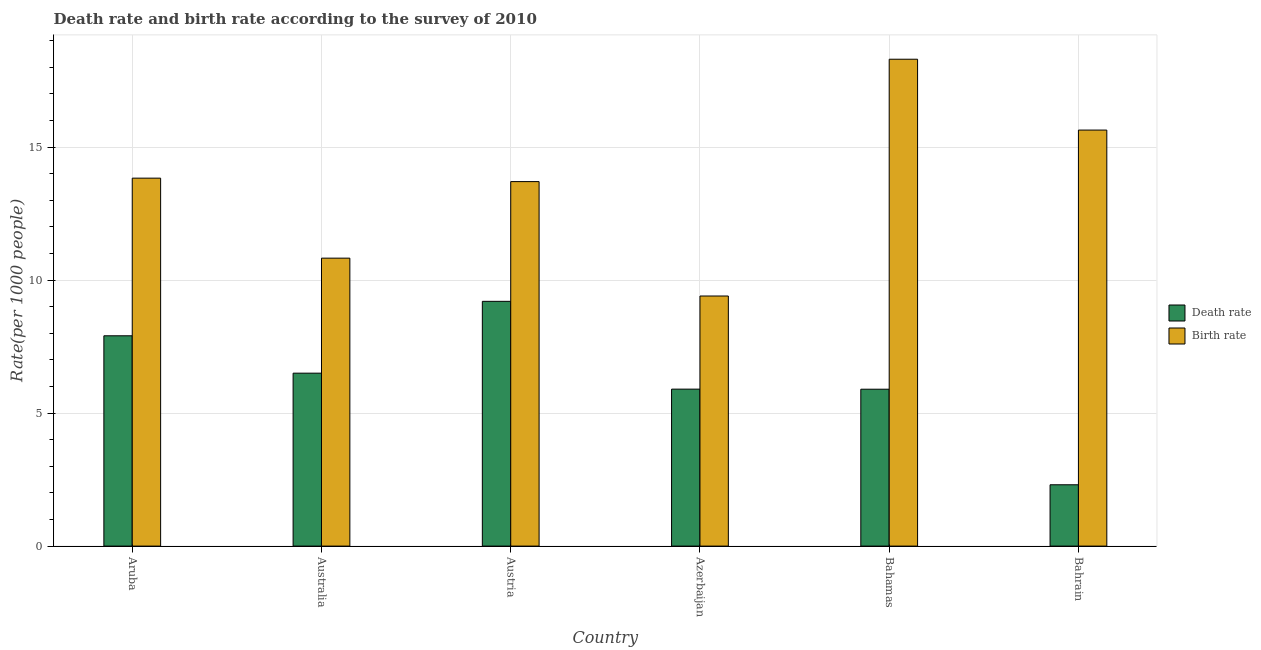How many different coloured bars are there?
Give a very brief answer. 2. How many groups of bars are there?
Give a very brief answer. 6. Are the number of bars on each tick of the X-axis equal?
Offer a very short reply. Yes. What is the label of the 1st group of bars from the left?
Offer a terse response. Aruba. In how many cases, is the number of bars for a given country not equal to the number of legend labels?
Ensure brevity in your answer.  0. What is the birth rate in Aruba?
Provide a short and direct response. 13.83. Across all countries, what is the maximum death rate?
Give a very brief answer. 9.2. Across all countries, what is the minimum birth rate?
Make the answer very short. 9.4. In which country was the death rate maximum?
Keep it short and to the point. Austria. In which country was the death rate minimum?
Give a very brief answer. Bahrain. What is the total death rate in the graph?
Offer a terse response. 37.71. What is the difference between the death rate in Aruba and that in Australia?
Provide a short and direct response. 1.41. What is the difference between the death rate in Bahamas and the birth rate in Aruba?
Your answer should be compact. -7.93. What is the average death rate per country?
Your answer should be very brief. 6.28. What is the difference between the death rate and birth rate in Aruba?
Your response must be concise. -5.92. In how many countries, is the birth rate greater than 2 ?
Provide a short and direct response. 6. What is the ratio of the death rate in Aruba to that in Austria?
Provide a short and direct response. 0.86. Is the difference between the death rate in Aruba and Austria greater than the difference between the birth rate in Aruba and Austria?
Ensure brevity in your answer.  No. What is the difference between the highest and the second highest death rate?
Provide a short and direct response. 1.29. What is the difference between the highest and the lowest death rate?
Provide a short and direct response. 6.89. In how many countries, is the birth rate greater than the average birth rate taken over all countries?
Your answer should be very brief. 4. Is the sum of the birth rate in Austria and Bahrain greater than the maximum death rate across all countries?
Make the answer very short. Yes. What does the 1st bar from the left in Azerbaijan represents?
Ensure brevity in your answer.  Death rate. What does the 2nd bar from the right in Azerbaijan represents?
Offer a very short reply. Death rate. Are all the bars in the graph horizontal?
Make the answer very short. No. How many countries are there in the graph?
Give a very brief answer. 6. Does the graph contain any zero values?
Offer a very short reply. No. Does the graph contain grids?
Ensure brevity in your answer.  Yes. Where does the legend appear in the graph?
Ensure brevity in your answer.  Center right. How many legend labels are there?
Keep it short and to the point. 2. How are the legend labels stacked?
Provide a succinct answer. Vertical. What is the title of the graph?
Offer a very short reply. Death rate and birth rate according to the survey of 2010. Does "Male" appear as one of the legend labels in the graph?
Keep it short and to the point. No. What is the label or title of the Y-axis?
Give a very brief answer. Rate(per 1000 people). What is the Rate(per 1000 people) in Death rate in Aruba?
Give a very brief answer. 7.91. What is the Rate(per 1000 people) in Birth rate in Aruba?
Your answer should be very brief. 13.83. What is the Rate(per 1000 people) in Death rate in Australia?
Make the answer very short. 6.5. What is the Rate(per 1000 people) in Birth rate in Australia?
Your response must be concise. 10.82. What is the Rate(per 1000 people) in Death rate in Austria?
Provide a short and direct response. 9.2. What is the Rate(per 1000 people) in Death rate in Bahamas?
Provide a short and direct response. 5.9. What is the Rate(per 1000 people) of Death rate in Bahrain?
Offer a terse response. 2.31. What is the Rate(per 1000 people) in Birth rate in Bahrain?
Keep it short and to the point. 15.64. Across all countries, what is the maximum Rate(per 1000 people) of Death rate?
Ensure brevity in your answer.  9.2. Across all countries, what is the minimum Rate(per 1000 people) in Death rate?
Your answer should be compact. 2.31. Across all countries, what is the minimum Rate(per 1000 people) in Birth rate?
Offer a very short reply. 9.4. What is the total Rate(per 1000 people) of Death rate in the graph?
Keep it short and to the point. 37.71. What is the total Rate(per 1000 people) of Birth rate in the graph?
Give a very brief answer. 81.69. What is the difference between the Rate(per 1000 people) of Death rate in Aruba and that in Australia?
Your response must be concise. 1.41. What is the difference between the Rate(per 1000 people) of Birth rate in Aruba and that in Australia?
Keep it short and to the point. 3.01. What is the difference between the Rate(per 1000 people) of Death rate in Aruba and that in Austria?
Offer a very short reply. -1.29. What is the difference between the Rate(per 1000 people) of Birth rate in Aruba and that in Austria?
Offer a very short reply. 0.13. What is the difference between the Rate(per 1000 people) in Death rate in Aruba and that in Azerbaijan?
Ensure brevity in your answer.  2. What is the difference between the Rate(per 1000 people) in Birth rate in Aruba and that in Azerbaijan?
Offer a very short reply. 4.43. What is the difference between the Rate(per 1000 people) in Death rate in Aruba and that in Bahamas?
Offer a very short reply. 2.01. What is the difference between the Rate(per 1000 people) in Birth rate in Aruba and that in Bahamas?
Your answer should be compact. -4.47. What is the difference between the Rate(per 1000 people) in Death rate in Aruba and that in Bahrain?
Your response must be concise. 5.6. What is the difference between the Rate(per 1000 people) in Birth rate in Aruba and that in Bahrain?
Provide a short and direct response. -1.81. What is the difference between the Rate(per 1000 people) of Birth rate in Australia and that in Austria?
Give a very brief answer. -2.88. What is the difference between the Rate(per 1000 people) in Death rate in Australia and that in Azerbaijan?
Provide a succinct answer. 0.6. What is the difference between the Rate(per 1000 people) in Birth rate in Australia and that in Azerbaijan?
Your answer should be very brief. 1.42. What is the difference between the Rate(per 1000 people) of Death rate in Australia and that in Bahamas?
Your answer should be compact. 0.6. What is the difference between the Rate(per 1000 people) of Birth rate in Australia and that in Bahamas?
Your response must be concise. -7.48. What is the difference between the Rate(per 1000 people) of Death rate in Australia and that in Bahrain?
Make the answer very short. 4.2. What is the difference between the Rate(per 1000 people) in Birth rate in Australia and that in Bahrain?
Your answer should be compact. -4.81. What is the difference between the Rate(per 1000 people) in Death rate in Austria and that in Azerbaijan?
Your response must be concise. 3.3. What is the difference between the Rate(per 1000 people) of Birth rate in Austria and that in Azerbaijan?
Your answer should be very brief. 4.3. What is the difference between the Rate(per 1000 people) in Death rate in Austria and that in Bahamas?
Offer a very short reply. 3.3. What is the difference between the Rate(per 1000 people) in Death rate in Austria and that in Bahrain?
Keep it short and to the point. 6.89. What is the difference between the Rate(per 1000 people) in Birth rate in Austria and that in Bahrain?
Provide a short and direct response. -1.94. What is the difference between the Rate(per 1000 people) in Death rate in Azerbaijan and that in Bahamas?
Give a very brief answer. 0. What is the difference between the Rate(per 1000 people) in Death rate in Azerbaijan and that in Bahrain?
Offer a very short reply. 3.6. What is the difference between the Rate(per 1000 people) of Birth rate in Azerbaijan and that in Bahrain?
Give a very brief answer. -6.24. What is the difference between the Rate(per 1000 people) of Death rate in Bahamas and that in Bahrain?
Ensure brevity in your answer.  3.59. What is the difference between the Rate(per 1000 people) in Birth rate in Bahamas and that in Bahrain?
Provide a short and direct response. 2.66. What is the difference between the Rate(per 1000 people) of Death rate in Aruba and the Rate(per 1000 people) of Birth rate in Australia?
Your answer should be compact. -2.92. What is the difference between the Rate(per 1000 people) in Death rate in Aruba and the Rate(per 1000 people) in Birth rate in Austria?
Keep it short and to the point. -5.79. What is the difference between the Rate(per 1000 people) of Death rate in Aruba and the Rate(per 1000 people) of Birth rate in Azerbaijan?
Your response must be concise. -1.5. What is the difference between the Rate(per 1000 people) in Death rate in Aruba and the Rate(per 1000 people) in Birth rate in Bahamas?
Give a very brief answer. -10.39. What is the difference between the Rate(per 1000 people) of Death rate in Aruba and the Rate(per 1000 people) of Birth rate in Bahrain?
Give a very brief answer. -7.73. What is the difference between the Rate(per 1000 people) of Death rate in Australia and the Rate(per 1000 people) of Birth rate in Austria?
Make the answer very short. -7.2. What is the difference between the Rate(per 1000 people) of Death rate in Australia and the Rate(per 1000 people) of Birth rate in Azerbaijan?
Keep it short and to the point. -2.9. What is the difference between the Rate(per 1000 people) in Death rate in Australia and the Rate(per 1000 people) in Birth rate in Bahrain?
Your answer should be very brief. -9.14. What is the difference between the Rate(per 1000 people) of Death rate in Austria and the Rate(per 1000 people) of Birth rate in Azerbaijan?
Ensure brevity in your answer.  -0.2. What is the difference between the Rate(per 1000 people) in Death rate in Austria and the Rate(per 1000 people) in Birth rate in Bahrain?
Ensure brevity in your answer.  -6.44. What is the difference between the Rate(per 1000 people) of Death rate in Azerbaijan and the Rate(per 1000 people) of Birth rate in Bahamas?
Your answer should be very brief. -12.4. What is the difference between the Rate(per 1000 people) in Death rate in Azerbaijan and the Rate(per 1000 people) in Birth rate in Bahrain?
Offer a terse response. -9.74. What is the difference between the Rate(per 1000 people) in Death rate in Bahamas and the Rate(per 1000 people) in Birth rate in Bahrain?
Your answer should be compact. -9.74. What is the average Rate(per 1000 people) of Death rate per country?
Provide a succinct answer. 6.28. What is the average Rate(per 1000 people) in Birth rate per country?
Ensure brevity in your answer.  13.62. What is the difference between the Rate(per 1000 people) of Death rate and Rate(per 1000 people) of Birth rate in Aruba?
Make the answer very short. -5.92. What is the difference between the Rate(per 1000 people) of Death rate and Rate(per 1000 people) of Birth rate in Australia?
Ensure brevity in your answer.  -4.32. What is the difference between the Rate(per 1000 people) in Death rate and Rate(per 1000 people) in Birth rate in Bahamas?
Offer a very short reply. -12.4. What is the difference between the Rate(per 1000 people) in Death rate and Rate(per 1000 people) in Birth rate in Bahrain?
Provide a succinct answer. -13.33. What is the ratio of the Rate(per 1000 people) of Death rate in Aruba to that in Australia?
Offer a very short reply. 1.22. What is the ratio of the Rate(per 1000 people) in Birth rate in Aruba to that in Australia?
Your answer should be compact. 1.28. What is the ratio of the Rate(per 1000 people) of Death rate in Aruba to that in Austria?
Give a very brief answer. 0.86. What is the ratio of the Rate(per 1000 people) of Birth rate in Aruba to that in Austria?
Make the answer very short. 1.01. What is the ratio of the Rate(per 1000 people) of Death rate in Aruba to that in Azerbaijan?
Your answer should be compact. 1.34. What is the ratio of the Rate(per 1000 people) in Birth rate in Aruba to that in Azerbaijan?
Provide a succinct answer. 1.47. What is the ratio of the Rate(per 1000 people) of Death rate in Aruba to that in Bahamas?
Give a very brief answer. 1.34. What is the ratio of the Rate(per 1000 people) of Birth rate in Aruba to that in Bahamas?
Offer a terse response. 0.76. What is the ratio of the Rate(per 1000 people) of Death rate in Aruba to that in Bahrain?
Make the answer very short. 3.43. What is the ratio of the Rate(per 1000 people) of Birth rate in Aruba to that in Bahrain?
Give a very brief answer. 0.88. What is the ratio of the Rate(per 1000 people) of Death rate in Australia to that in Austria?
Make the answer very short. 0.71. What is the ratio of the Rate(per 1000 people) in Birth rate in Australia to that in Austria?
Your answer should be very brief. 0.79. What is the ratio of the Rate(per 1000 people) in Death rate in Australia to that in Azerbaijan?
Provide a succinct answer. 1.1. What is the ratio of the Rate(per 1000 people) in Birth rate in Australia to that in Azerbaijan?
Offer a terse response. 1.15. What is the ratio of the Rate(per 1000 people) of Death rate in Australia to that in Bahamas?
Offer a very short reply. 1.1. What is the ratio of the Rate(per 1000 people) of Birth rate in Australia to that in Bahamas?
Provide a succinct answer. 0.59. What is the ratio of the Rate(per 1000 people) of Death rate in Australia to that in Bahrain?
Offer a terse response. 2.82. What is the ratio of the Rate(per 1000 people) of Birth rate in Australia to that in Bahrain?
Provide a short and direct response. 0.69. What is the ratio of the Rate(per 1000 people) in Death rate in Austria to that in Azerbaijan?
Your answer should be compact. 1.56. What is the ratio of the Rate(per 1000 people) of Birth rate in Austria to that in Azerbaijan?
Ensure brevity in your answer.  1.46. What is the ratio of the Rate(per 1000 people) of Death rate in Austria to that in Bahamas?
Your response must be concise. 1.56. What is the ratio of the Rate(per 1000 people) of Birth rate in Austria to that in Bahamas?
Offer a very short reply. 0.75. What is the ratio of the Rate(per 1000 people) of Death rate in Austria to that in Bahrain?
Provide a succinct answer. 3.99. What is the ratio of the Rate(per 1000 people) in Birth rate in Austria to that in Bahrain?
Your answer should be compact. 0.88. What is the ratio of the Rate(per 1000 people) of Birth rate in Azerbaijan to that in Bahamas?
Your response must be concise. 0.51. What is the ratio of the Rate(per 1000 people) in Death rate in Azerbaijan to that in Bahrain?
Your answer should be very brief. 2.56. What is the ratio of the Rate(per 1000 people) of Birth rate in Azerbaijan to that in Bahrain?
Provide a succinct answer. 0.6. What is the ratio of the Rate(per 1000 people) of Death rate in Bahamas to that in Bahrain?
Offer a terse response. 2.56. What is the ratio of the Rate(per 1000 people) in Birth rate in Bahamas to that in Bahrain?
Your response must be concise. 1.17. What is the difference between the highest and the second highest Rate(per 1000 people) of Death rate?
Make the answer very short. 1.29. What is the difference between the highest and the second highest Rate(per 1000 people) of Birth rate?
Make the answer very short. 2.66. What is the difference between the highest and the lowest Rate(per 1000 people) of Death rate?
Offer a very short reply. 6.89. 